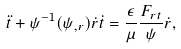Convert formula to latex. <formula><loc_0><loc_0><loc_500><loc_500>\ddot { t } + \psi ^ { - 1 } ( \psi _ { , r } ) \dot { r } \dot { t } = \frac { \epsilon } { \mu } \frac { F _ { r t } } { \psi } \dot { r } ,</formula> 